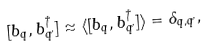Convert formula to latex. <formula><loc_0><loc_0><loc_500><loc_500>[ b _ { q } , b ^ { \dagger } _ { q ^ { \prime } } ] \approx \langle [ b _ { q } , b ^ { \dagger } _ { q ^ { \prime } } ] \rangle = \delta _ { q , q ^ { \prime } } ,</formula> 